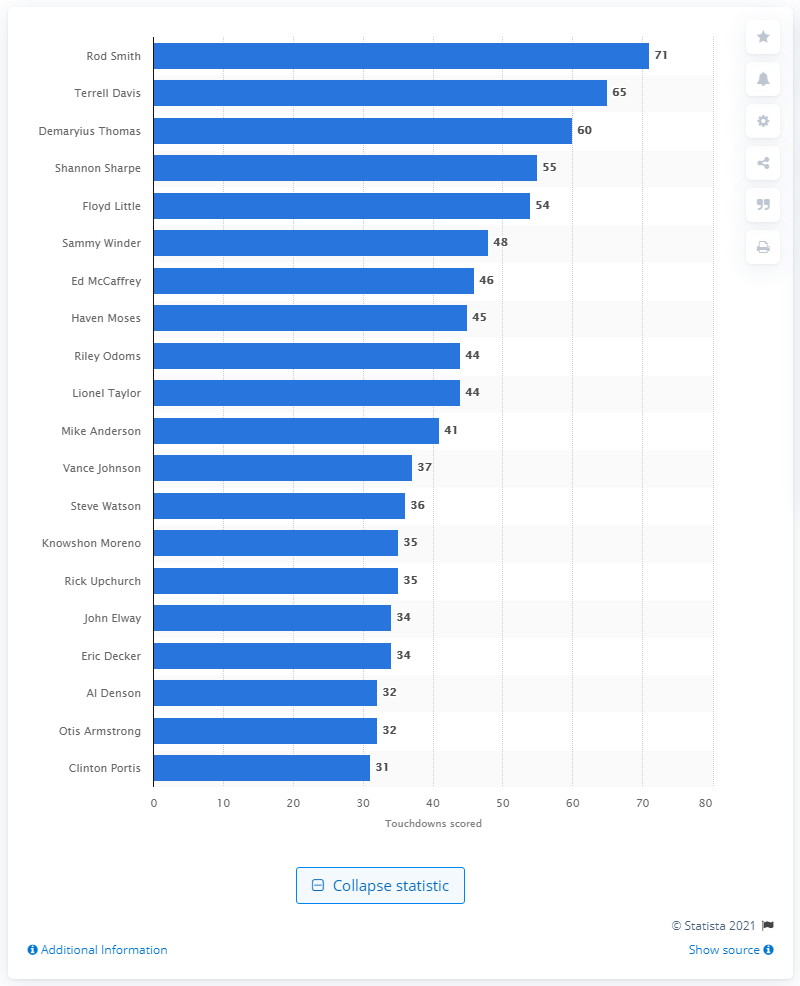List a handful of essential elements in this visual. Rod Smith is the career touchdown leader of the Denver Broncos. Rod Smith has scored 71 career touchdowns for the Denver Broncos. 